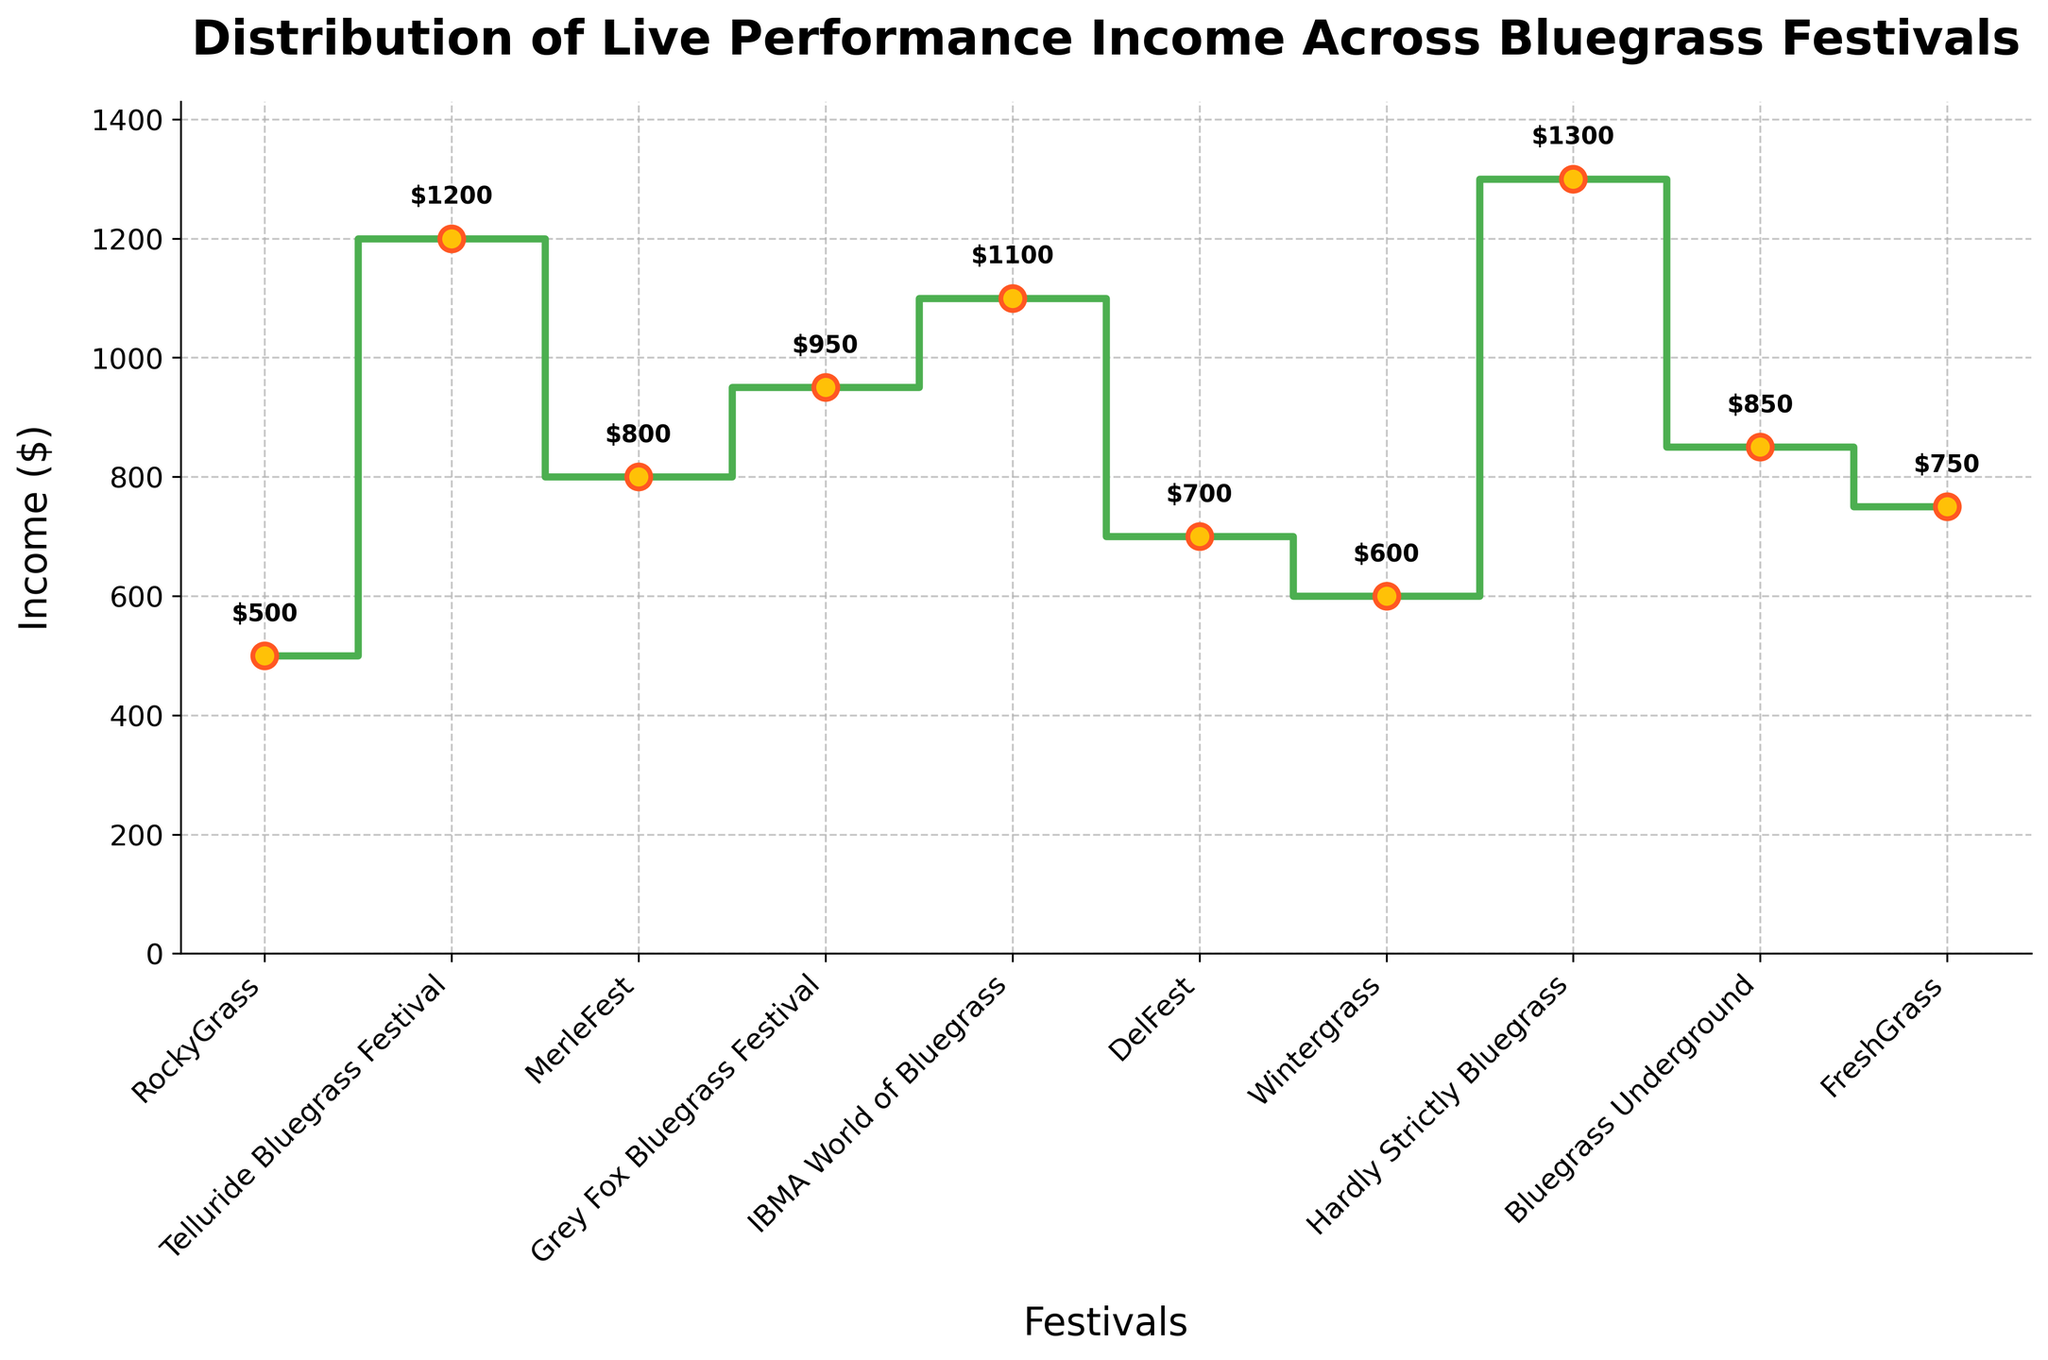What festival has the highest income according to the plot? From the plot, we can see that the highest value on the y-axis corresponds to the Hardly Strictly Bluegrass festival.
Answer: Hardly Strictly Bluegrass What is the title of the plot? The title is displayed at the top of the plot. It reads "Distribution of Live Performance Income Across Bluegrass Festivals."
Answer: Distribution of Live Performance Income Across Bluegrass Festivals What is the range of income values shown in the plot? To find the range, subtract the smallest income value from the largest. The smallest value is for RockyGrass ($500) and the largest is for Hardly Strictly Bluegrass ($1300). So, 1300 - 500 = 800.
Answer: 800 What is the average income across all the festivals? Sum up all the income values and divide by the number of festivals: (500 + 1200 + 800 + 950 + 1100 + 700 + 600 + 1300 + 850 + 750) / 10. The total is 8750, so the average is 8750 / 10 = 875.
Answer: 875 Which festival has the nearest income value to $1000? From the plot, identify the income values closest to $1000. IBMA World of Bluegrass is nearest with an income of $1100.
Answer: IBMA World of Bluegrass Which festivals have an income greater than $1000? Check the plot for income values higher than $1000. These festivals are Telluride Bluegrass ($1200), IBMA World of Bluegrass ($1100), and Hardly Strictly Bluegrass ($1300).
Answer: Telluride Bluegrass, IBMA World of Bluegrass, Hardly Strictly Bluegrass By how much does the income at Telluride Bluegrass Festival exceed that at RockyGrass? Subtract the income of RockyGrass from that of Telluride Bluegrass. 1200 - 500 = 700.
Answer: 700 What is the median income value across the festivals? List the values in ascending order and find the middle value(s): 500, 600, 700, 750, 800, 850, 950, 1100, 1200, 1300. There are 10 values, so the median is the average of the 5th and 6th values: (800 + 850) / 2 = 825.
Answer: 825 Which festival shows an income value exactly at the midpoint of the incomes? Identify the midpoint of the income range (500 to 1300). Since the midpoint is (500 + 1300)/2 = 900, no festival exactly matches this value, but Grey Fox Bluegrass Festival has an income close to this value at $950.
Answer: Grey Fox Bluegrass Festival How many festivals have an income value below the average income? First, recall the average income is $875. Then, count the number of festivals below this value. Festivals under $875 are RockyGrass, DelFest, Wintergrass, and FreshGrass, thus making it 4 festivals.
Answer: 4 